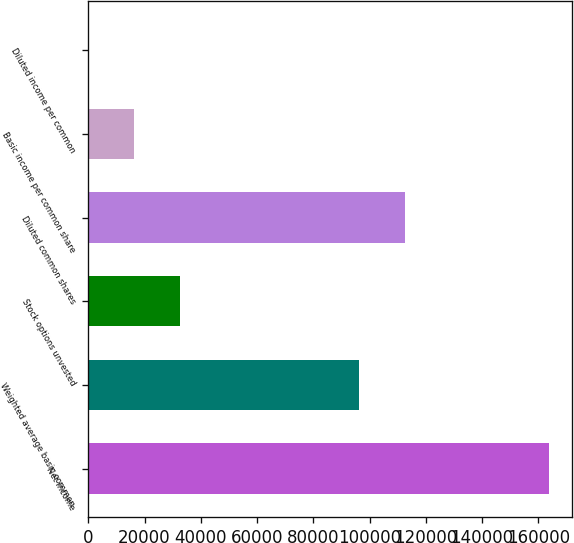Convert chart to OTSL. <chart><loc_0><loc_0><loc_500><loc_500><bar_chart><fcel>Net income<fcel>Weighted average basic common<fcel>Stock options unvested<fcel>Diluted common shares<fcel>Basic income per common share<fcel>Diluted income per common<nl><fcel>163820<fcel>96384<fcel>32765.3<fcel>112766<fcel>16383.5<fcel>1.68<nl></chart> 